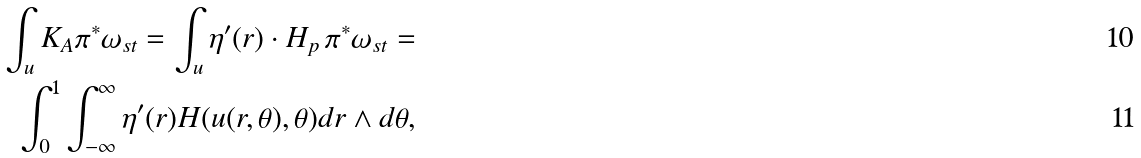<formula> <loc_0><loc_0><loc_500><loc_500>\int _ { u } K _ { A } \pi ^ { * } \omega _ { s t } = \int _ { u } \eta ^ { \prime } ( r ) \cdot H _ { p } \, \pi ^ { * } \omega _ { s t } = \\ \int _ { 0 } ^ { 1 } \int _ { - \infty } ^ { \infty } \eta ^ { \prime } ( r ) H ( u ( r , \theta ) , \theta ) d r \wedge d \theta ,</formula> 